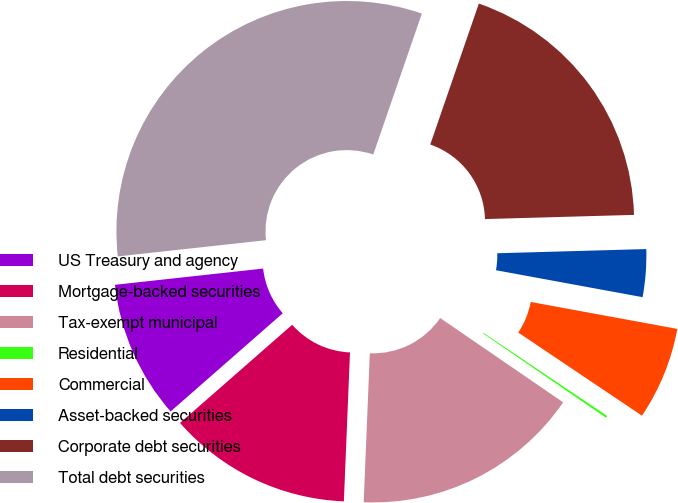<chart> <loc_0><loc_0><loc_500><loc_500><pie_chart><fcel>US Treasury and agency<fcel>Mortgage-backed securities<fcel>Tax-exempt municipal<fcel>Residential<fcel>Commercial<fcel>Asset-backed securities<fcel>Corporate debt securities<fcel>Total debt securities<nl><fcel>9.71%<fcel>12.9%<fcel>16.09%<fcel>0.15%<fcel>6.52%<fcel>3.34%<fcel>19.27%<fcel>32.02%<nl></chart> 